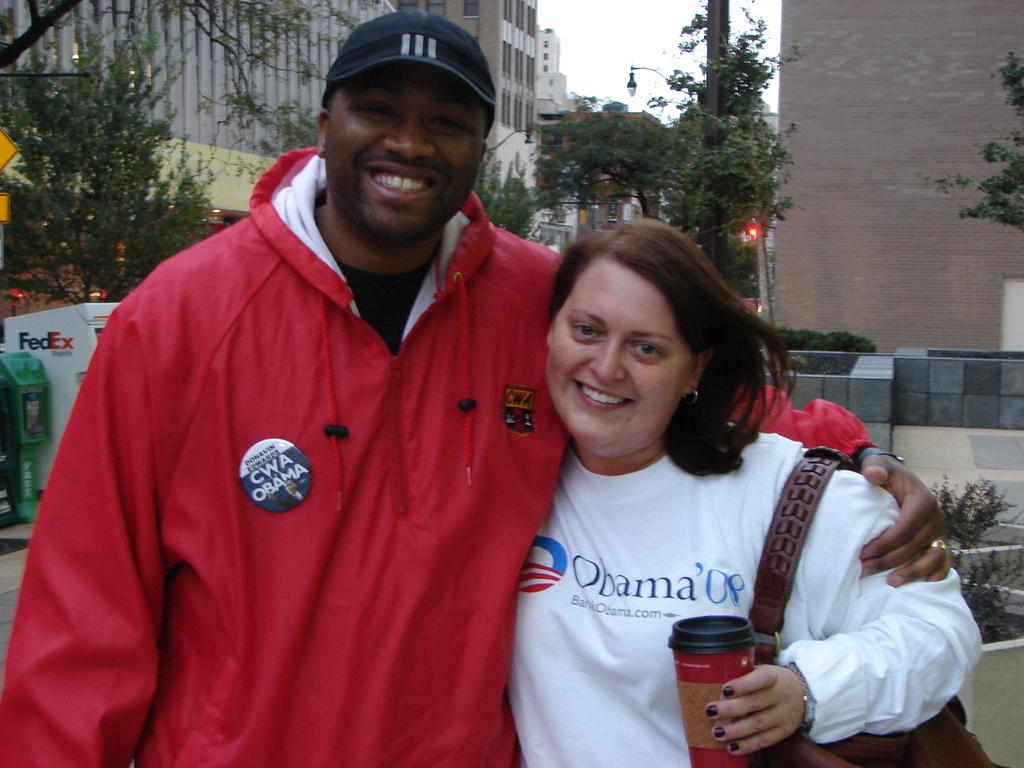<image>
Render a clear and concise summary of the photo. The girl in the white shirt has obama 08 on the front 